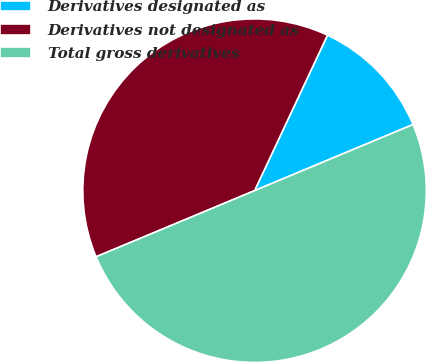Convert chart. <chart><loc_0><loc_0><loc_500><loc_500><pie_chart><fcel>Derivatives designated as<fcel>Derivatives not designated as<fcel>Total gross derivatives<nl><fcel>11.73%<fcel>38.27%<fcel>50.0%<nl></chart> 